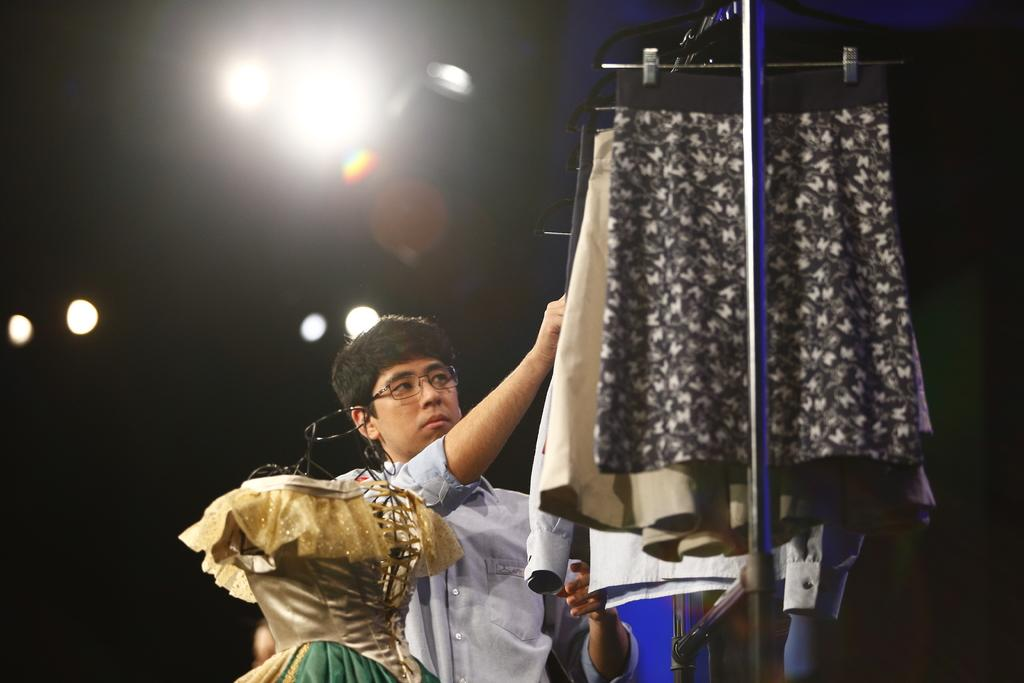What is the person in the image holding? The person is holding clothes in the image. How are the clothes arranged in the image? Clothes are hanging on a metal rod in the image. What can be seen on the left side of the image? There is a mannequin on the left side of the image. What is attached to the roof on the left side of the image? Lights are attached to the roof on the left side of the image. Can you see any veins in the clothes hanging on the metal rod? There are no veins visible in the image, as veins are a part of living organisms and not present in clothes or metal rods. 